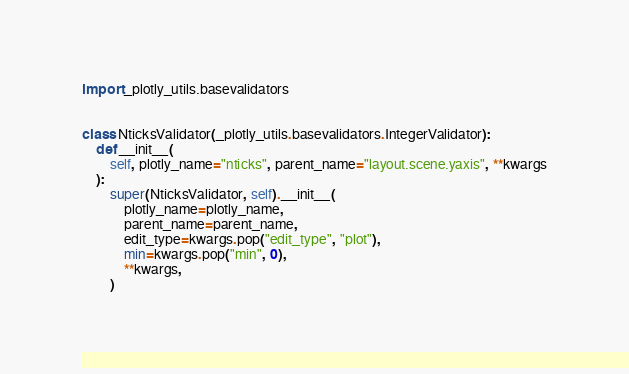Convert code to text. <code><loc_0><loc_0><loc_500><loc_500><_Python_>import _plotly_utils.basevalidators


class NticksValidator(_plotly_utils.basevalidators.IntegerValidator):
    def __init__(
        self, plotly_name="nticks", parent_name="layout.scene.yaxis", **kwargs
    ):
        super(NticksValidator, self).__init__(
            plotly_name=plotly_name,
            parent_name=parent_name,
            edit_type=kwargs.pop("edit_type", "plot"),
            min=kwargs.pop("min", 0),
            **kwargs,
        )
</code> 